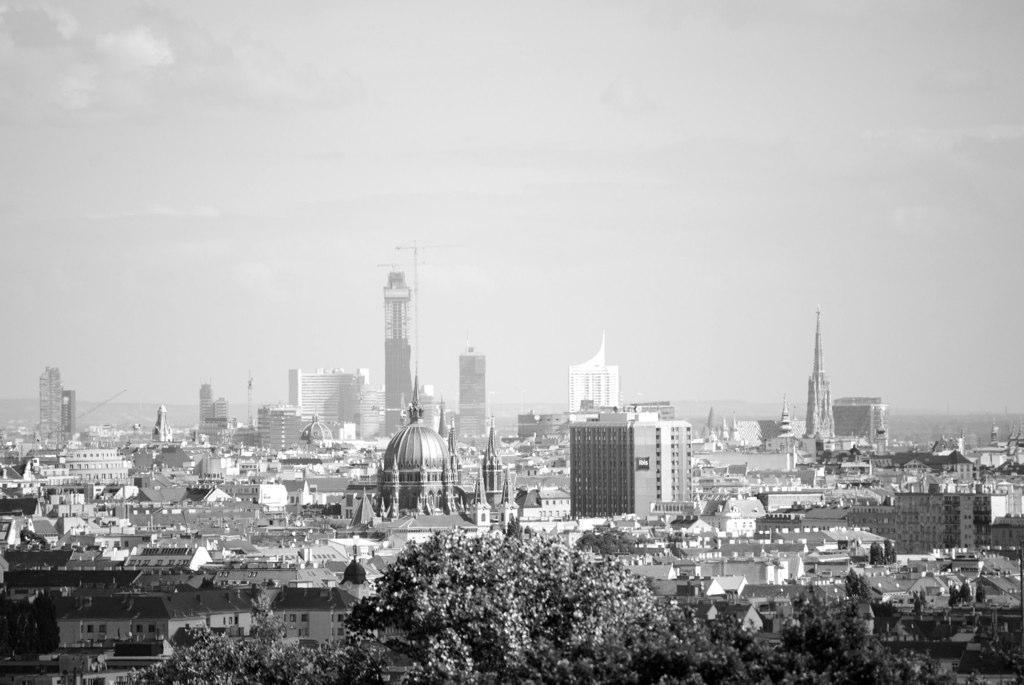What is the color scheme of the image? The image is in black and white. What can be seen at the bottom of the image? There are buildings and trees at the bottom of the image. What is visible at the top of the image? The sky is visible at the top of the image. What can be observed in the sky? Clouds are present in the sky. What type of oatmeal is being served in the image? There is no oatmeal present in the image. What property is being sold in the image? There is no property being sold in the image. Are there any icicles visible in the image? There are no icicles present in the image. 